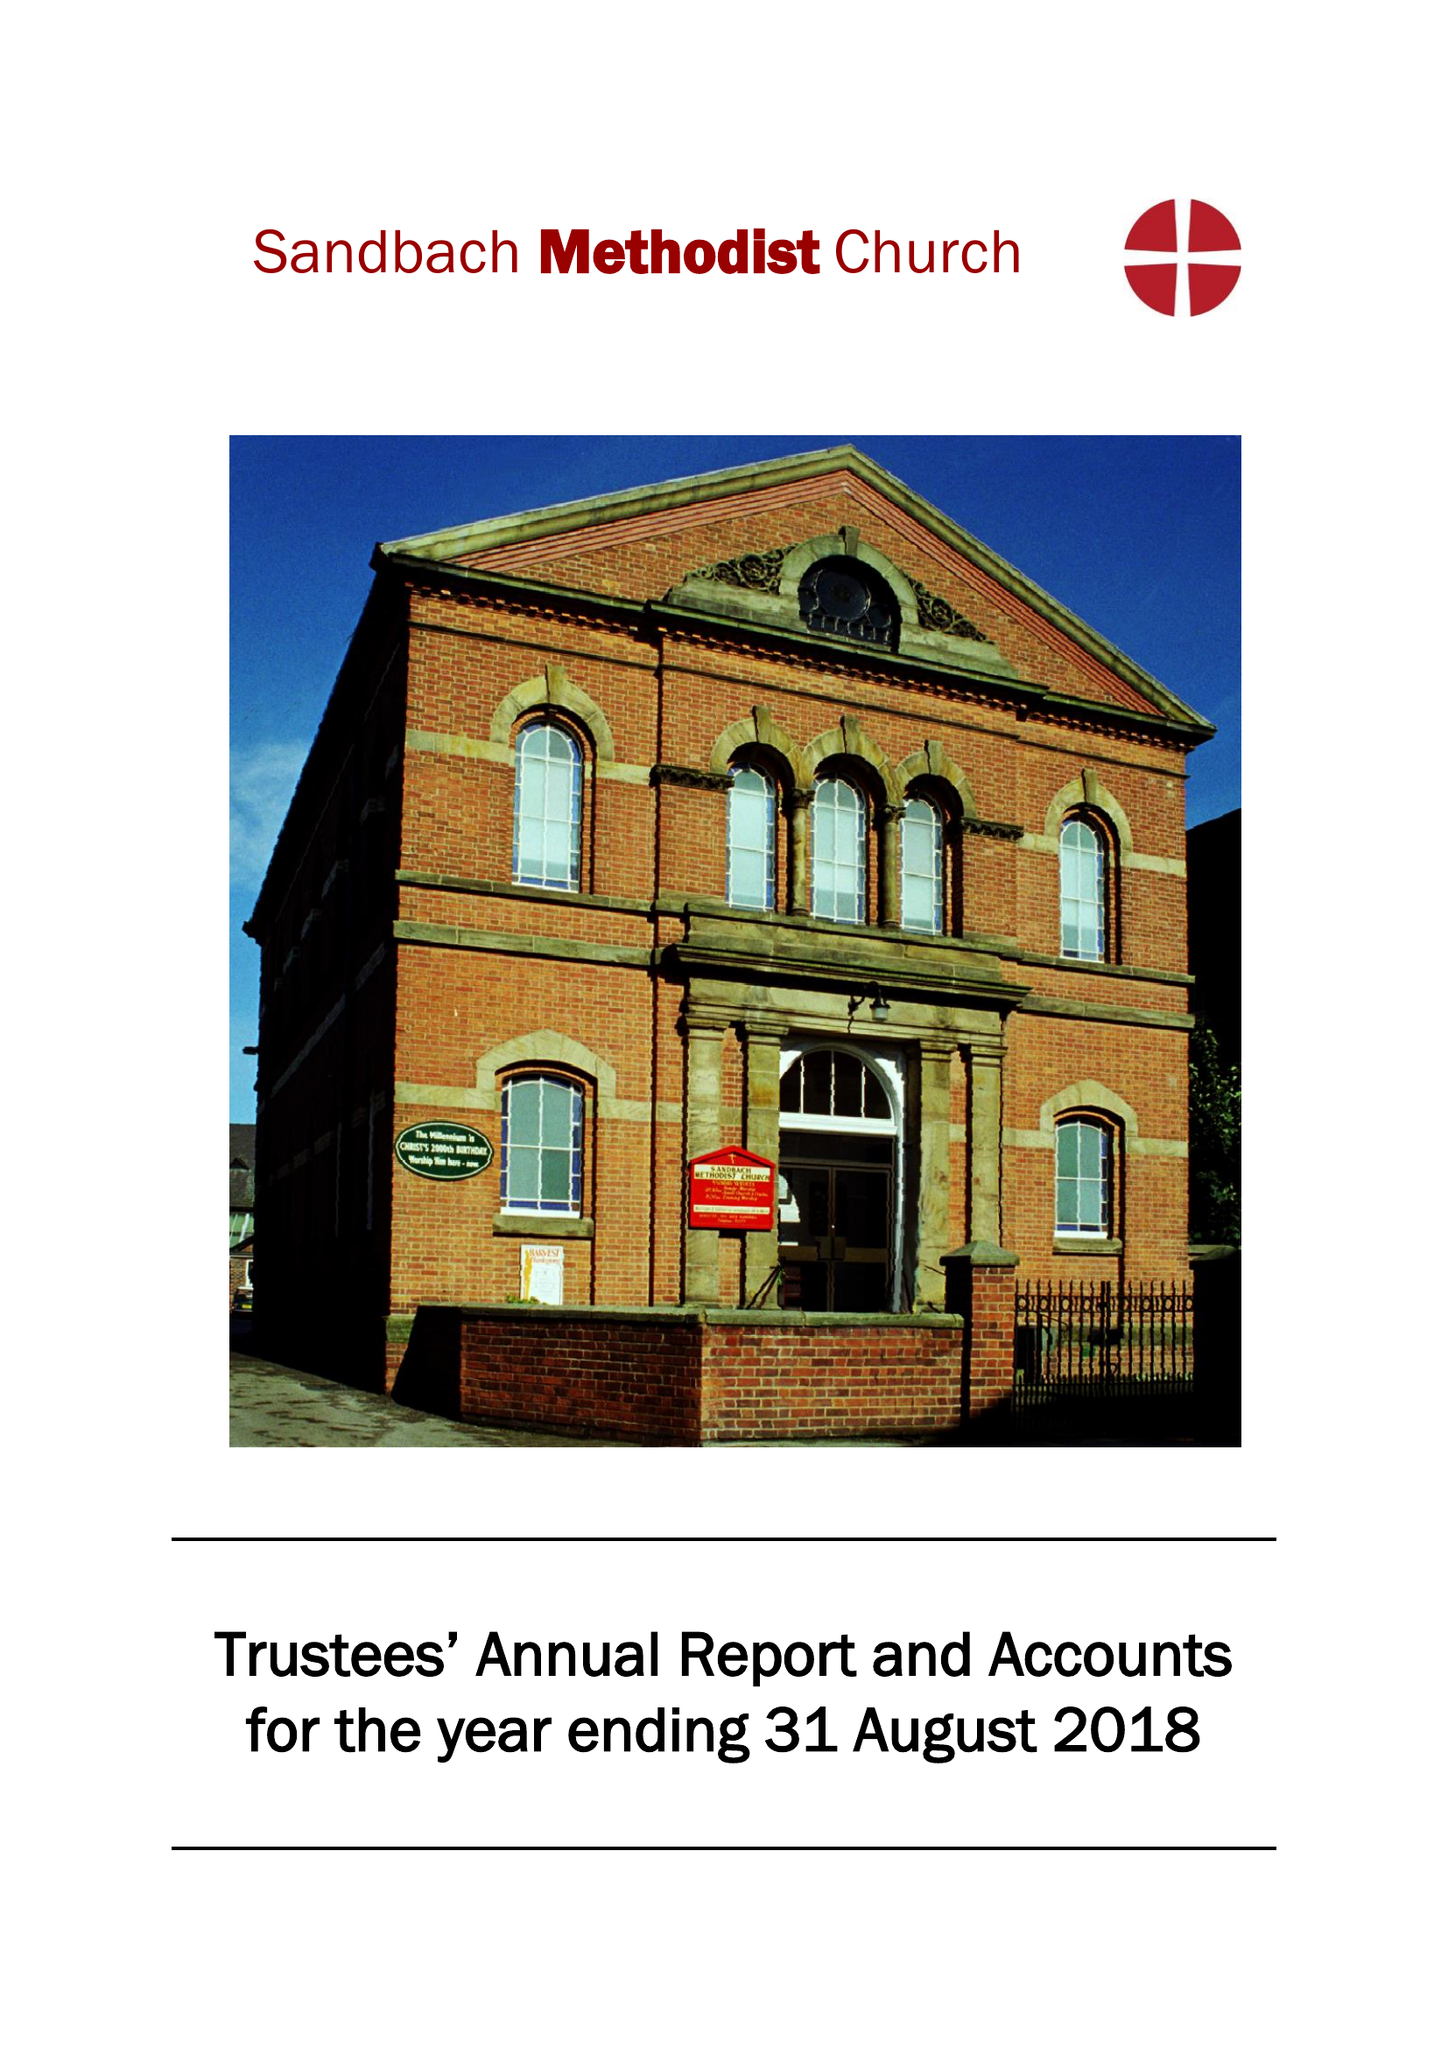What is the value for the address__postcode?
Answer the question using a single word or phrase. CW11 1DG 